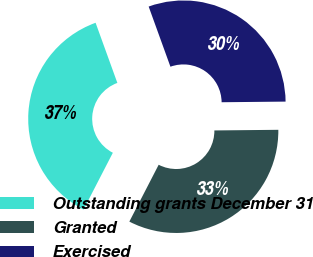<chart> <loc_0><loc_0><loc_500><loc_500><pie_chart><fcel>Outstanding grants December 31<fcel>Granted<fcel>Exercised<nl><fcel>36.89%<fcel>32.74%<fcel>30.37%<nl></chart> 